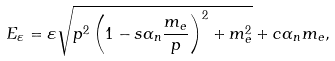<formula> <loc_0><loc_0><loc_500><loc_500>E _ { \varepsilon } = \varepsilon { \sqrt { { p } ^ { 2 } \left ( 1 - s \alpha _ { n } \frac { m _ { e } } { p } \right ) ^ { 2 } + m _ { e } ^ { 2 } } + c \alpha _ { n } m _ { e } } ,</formula> 